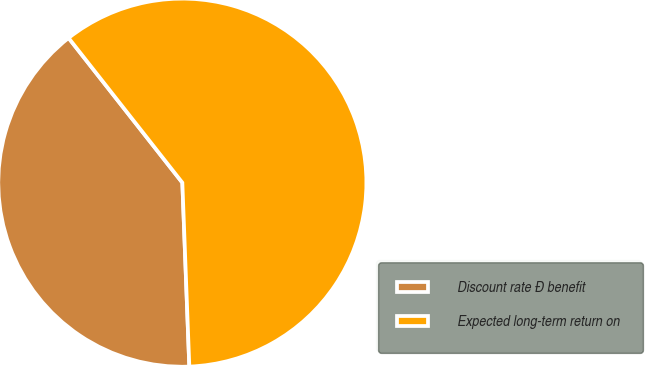Convert chart to OTSL. <chart><loc_0><loc_0><loc_500><loc_500><pie_chart><fcel>Discount rate Ð benefit<fcel>Expected long-term return on<nl><fcel>40.0%<fcel>60.0%<nl></chart> 